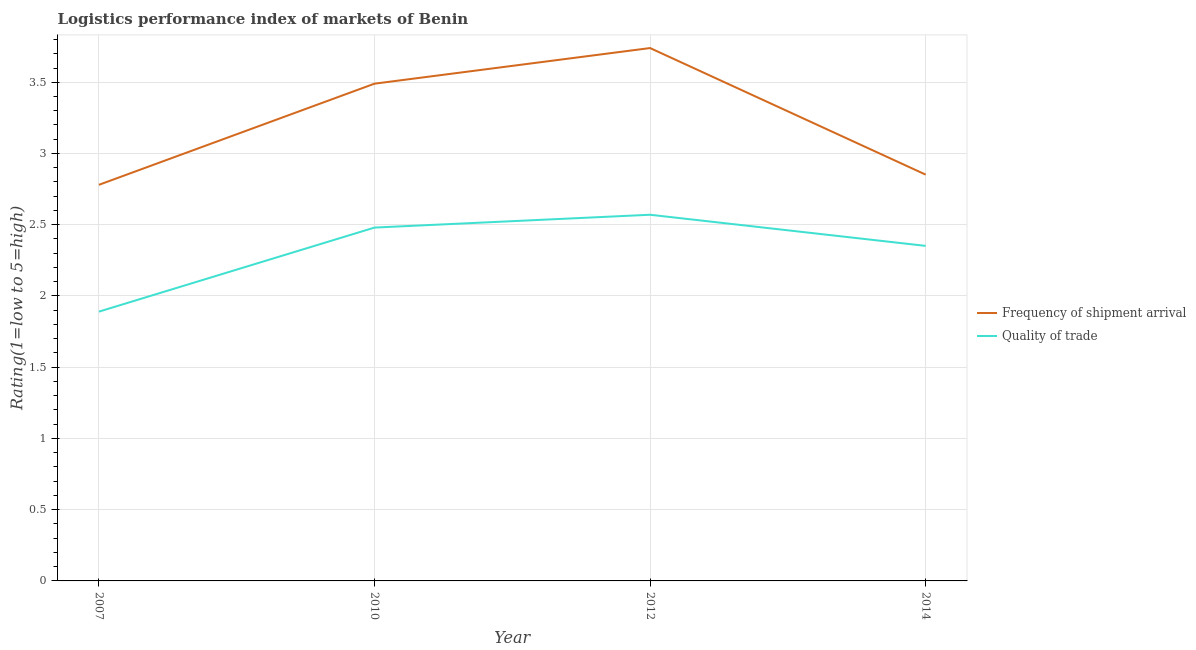How many different coloured lines are there?
Provide a short and direct response. 2. Does the line corresponding to lpi of frequency of shipment arrival intersect with the line corresponding to lpi quality of trade?
Your answer should be very brief. No. Is the number of lines equal to the number of legend labels?
Give a very brief answer. Yes. What is the lpi of frequency of shipment arrival in 2014?
Make the answer very short. 2.85. Across all years, what is the maximum lpi of frequency of shipment arrival?
Your response must be concise. 3.74. Across all years, what is the minimum lpi quality of trade?
Provide a succinct answer. 1.89. In which year was the lpi of frequency of shipment arrival minimum?
Your answer should be very brief. 2007. What is the total lpi of frequency of shipment arrival in the graph?
Your answer should be compact. 12.86. What is the difference between the lpi quality of trade in 2007 and that in 2012?
Provide a short and direct response. -0.68. What is the difference between the lpi quality of trade in 2012 and the lpi of frequency of shipment arrival in 2007?
Keep it short and to the point. -0.21. What is the average lpi of frequency of shipment arrival per year?
Provide a short and direct response. 3.22. In the year 2007, what is the difference between the lpi of frequency of shipment arrival and lpi quality of trade?
Offer a very short reply. 0.89. In how many years, is the lpi quality of trade greater than 3.6?
Your answer should be compact. 0. What is the ratio of the lpi quality of trade in 2012 to that in 2014?
Ensure brevity in your answer.  1.09. Is the lpi quality of trade in 2010 less than that in 2012?
Keep it short and to the point. Yes. What is the difference between the highest and the second highest lpi quality of trade?
Offer a very short reply. 0.09. What is the difference between the highest and the lowest lpi of frequency of shipment arrival?
Give a very brief answer. 0.96. Is the sum of the lpi of frequency of shipment arrival in 2010 and 2012 greater than the maximum lpi quality of trade across all years?
Your response must be concise. Yes. Does the lpi quality of trade monotonically increase over the years?
Make the answer very short. No. Is the lpi of frequency of shipment arrival strictly greater than the lpi quality of trade over the years?
Provide a short and direct response. Yes. How many lines are there?
Ensure brevity in your answer.  2. How many years are there in the graph?
Ensure brevity in your answer.  4. Are the values on the major ticks of Y-axis written in scientific E-notation?
Offer a very short reply. No. Does the graph contain any zero values?
Your response must be concise. No. How many legend labels are there?
Make the answer very short. 2. What is the title of the graph?
Your answer should be compact. Logistics performance index of markets of Benin. What is the label or title of the X-axis?
Your answer should be very brief. Year. What is the label or title of the Y-axis?
Your answer should be very brief. Rating(1=low to 5=high). What is the Rating(1=low to 5=high) in Frequency of shipment arrival in 2007?
Provide a succinct answer. 2.78. What is the Rating(1=low to 5=high) of Quality of trade in 2007?
Provide a short and direct response. 1.89. What is the Rating(1=low to 5=high) in Frequency of shipment arrival in 2010?
Offer a terse response. 3.49. What is the Rating(1=low to 5=high) in Quality of trade in 2010?
Ensure brevity in your answer.  2.48. What is the Rating(1=low to 5=high) of Frequency of shipment arrival in 2012?
Your answer should be compact. 3.74. What is the Rating(1=low to 5=high) of Quality of trade in 2012?
Your answer should be very brief. 2.57. What is the Rating(1=low to 5=high) in Frequency of shipment arrival in 2014?
Keep it short and to the point. 2.85. What is the Rating(1=low to 5=high) in Quality of trade in 2014?
Your answer should be compact. 2.35. Across all years, what is the maximum Rating(1=low to 5=high) in Frequency of shipment arrival?
Your answer should be very brief. 3.74. Across all years, what is the maximum Rating(1=low to 5=high) in Quality of trade?
Your answer should be compact. 2.57. Across all years, what is the minimum Rating(1=low to 5=high) in Frequency of shipment arrival?
Offer a very short reply. 2.78. Across all years, what is the minimum Rating(1=low to 5=high) in Quality of trade?
Make the answer very short. 1.89. What is the total Rating(1=low to 5=high) of Frequency of shipment arrival in the graph?
Make the answer very short. 12.86. What is the total Rating(1=low to 5=high) in Quality of trade in the graph?
Ensure brevity in your answer.  9.29. What is the difference between the Rating(1=low to 5=high) of Frequency of shipment arrival in 2007 and that in 2010?
Offer a very short reply. -0.71. What is the difference between the Rating(1=low to 5=high) of Quality of trade in 2007 and that in 2010?
Your answer should be very brief. -0.59. What is the difference between the Rating(1=low to 5=high) in Frequency of shipment arrival in 2007 and that in 2012?
Your response must be concise. -0.96. What is the difference between the Rating(1=low to 5=high) of Quality of trade in 2007 and that in 2012?
Keep it short and to the point. -0.68. What is the difference between the Rating(1=low to 5=high) in Frequency of shipment arrival in 2007 and that in 2014?
Your response must be concise. -0.07. What is the difference between the Rating(1=low to 5=high) in Quality of trade in 2007 and that in 2014?
Ensure brevity in your answer.  -0.46. What is the difference between the Rating(1=low to 5=high) of Frequency of shipment arrival in 2010 and that in 2012?
Give a very brief answer. -0.25. What is the difference between the Rating(1=low to 5=high) of Quality of trade in 2010 and that in 2012?
Offer a very short reply. -0.09. What is the difference between the Rating(1=low to 5=high) in Frequency of shipment arrival in 2010 and that in 2014?
Offer a terse response. 0.64. What is the difference between the Rating(1=low to 5=high) in Quality of trade in 2010 and that in 2014?
Make the answer very short. 0.13. What is the difference between the Rating(1=low to 5=high) of Frequency of shipment arrival in 2012 and that in 2014?
Your response must be concise. 0.89. What is the difference between the Rating(1=low to 5=high) in Quality of trade in 2012 and that in 2014?
Your response must be concise. 0.22. What is the difference between the Rating(1=low to 5=high) in Frequency of shipment arrival in 2007 and the Rating(1=low to 5=high) in Quality of trade in 2012?
Keep it short and to the point. 0.21. What is the difference between the Rating(1=low to 5=high) of Frequency of shipment arrival in 2007 and the Rating(1=low to 5=high) of Quality of trade in 2014?
Provide a succinct answer. 0.43. What is the difference between the Rating(1=low to 5=high) of Frequency of shipment arrival in 2010 and the Rating(1=low to 5=high) of Quality of trade in 2012?
Provide a succinct answer. 0.92. What is the difference between the Rating(1=low to 5=high) of Frequency of shipment arrival in 2010 and the Rating(1=low to 5=high) of Quality of trade in 2014?
Give a very brief answer. 1.14. What is the difference between the Rating(1=low to 5=high) of Frequency of shipment arrival in 2012 and the Rating(1=low to 5=high) of Quality of trade in 2014?
Offer a terse response. 1.39. What is the average Rating(1=low to 5=high) of Frequency of shipment arrival per year?
Provide a short and direct response. 3.22. What is the average Rating(1=low to 5=high) of Quality of trade per year?
Ensure brevity in your answer.  2.32. In the year 2007, what is the difference between the Rating(1=low to 5=high) of Frequency of shipment arrival and Rating(1=low to 5=high) of Quality of trade?
Offer a very short reply. 0.89. In the year 2010, what is the difference between the Rating(1=low to 5=high) of Frequency of shipment arrival and Rating(1=low to 5=high) of Quality of trade?
Make the answer very short. 1.01. In the year 2012, what is the difference between the Rating(1=low to 5=high) of Frequency of shipment arrival and Rating(1=low to 5=high) of Quality of trade?
Offer a very short reply. 1.17. In the year 2014, what is the difference between the Rating(1=low to 5=high) of Frequency of shipment arrival and Rating(1=low to 5=high) of Quality of trade?
Your answer should be very brief. 0.5. What is the ratio of the Rating(1=low to 5=high) of Frequency of shipment arrival in 2007 to that in 2010?
Make the answer very short. 0.8. What is the ratio of the Rating(1=low to 5=high) of Quality of trade in 2007 to that in 2010?
Your answer should be very brief. 0.76. What is the ratio of the Rating(1=low to 5=high) of Frequency of shipment arrival in 2007 to that in 2012?
Provide a succinct answer. 0.74. What is the ratio of the Rating(1=low to 5=high) of Quality of trade in 2007 to that in 2012?
Keep it short and to the point. 0.74. What is the ratio of the Rating(1=low to 5=high) of Frequency of shipment arrival in 2007 to that in 2014?
Offer a terse response. 0.97. What is the ratio of the Rating(1=low to 5=high) in Quality of trade in 2007 to that in 2014?
Offer a terse response. 0.8. What is the ratio of the Rating(1=low to 5=high) of Frequency of shipment arrival in 2010 to that in 2012?
Your answer should be compact. 0.93. What is the ratio of the Rating(1=low to 5=high) of Quality of trade in 2010 to that in 2012?
Keep it short and to the point. 0.96. What is the ratio of the Rating(1=low to 5=high) in Frequency of shipment arrival in 2010 to that in 2014?
Offer a very short reply. 1.22. What is the ratio of the Rating(1=low to 5=high) in Quality of trade in 2010 to that in 2014?
Keep it short and to the point. 1.05. What is the ratio of the Rating(1=low to 5=high) of Frequency of shipment arrival in 2012 to that in 2014?
Your answer should be very brief. 1.31. What is the ratio of the Rating(1=low to 5=high) in Quality of trade in 2012 to that in 2014?
Your response must be concise. 1.09. What is the difference between the highest and the second highest Rating(1=low to 5=high) of Frequency of shipment arrival?
Your answer should be very brief. 0.25. What is the difference between the highest and the second highest Rating(1=low to 5=high) of Quality of trade?
Provide a short and direct response. 0.09. What is the difference between the highest and the lowest Rating(1=low to 5=high) in Frequency of shipment arrival?
Offer a very short reply. 0.96. What is the difference between the highest and the lowest Rating(1=low to 5=high) of Quality of trade?
Your answer should be compact. 0.68. 